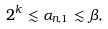<formula> <loc_0><loc_0><loc_500><loc_500>2 ^ { k } \lesssim \alpha _ { n , 1 } \lesssim \beta ,</formula> 